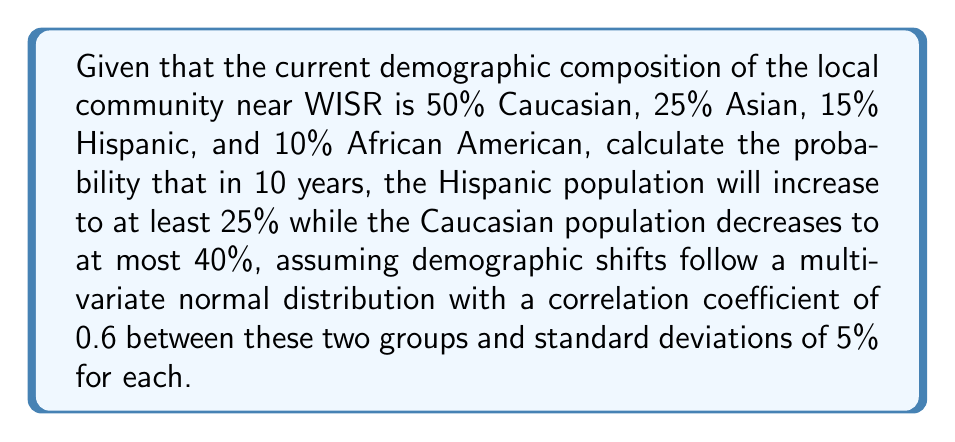Help me with this question. To solve this problem, we'll follow these steps:

1) First, we need to calculate the z-scores for both the Hispanic and Caucasian populations:

   For Hispanic: $z_H = \frac{25\% - 15\%}{5\%} = 2$
   For Caucasian: $z_C = \frac{40\% - 50\%}{5\%} = -2$

2) Now, we need to use the bivariate normal distribution. The probability we're looking for is:

   $P(Z_H \geq 2, Z_C \leq -2)$

3) For bivariate normal distribution with correlation $\rho$, we use the formula:

   $P(Z_1 \geq a, Z_2 \geq b) = \Phi(a) + \Phi(b) - 1 + P(Z_1 \leq -a, Z_2 \leq -b)$

   Where $\Phi$ is the standard normal cumulative distribution function.

4) In our case, we need:

   $P(Z_H \geq 2, Z_C \leq -2) = P(Z_H \geq 2, Z_C \geq 2)$
                                $= \Phi(-2) + \Phi(-2) - 1 + P(Z_H \leq 2, Z_C \leq 2)$

5) We can calculate $\Phi(-2)$ using a standard normal table or calculator:

   $\Phi(-2) \approx 0.02275$

6) For $P(Z_H \leq 2, Z_C \leq 2)$, we need to use the bivariate normal distribution function with $\rho = 0.6$:

   $P(Z_H \leq 2, Z_C \leq 2) \approx 0.9139$ (calculated using statistical software)

7) Putting it all together:

   $P(Z_H \geq 2, Z_C \leq -2) = 0.02275 + 0.02275 - 1 + 0.9139 = 0.03940$

Therefore, the probability is approximately 0.03940 or 3.94%.
Answer: 0.03940 (or 3.94%) 